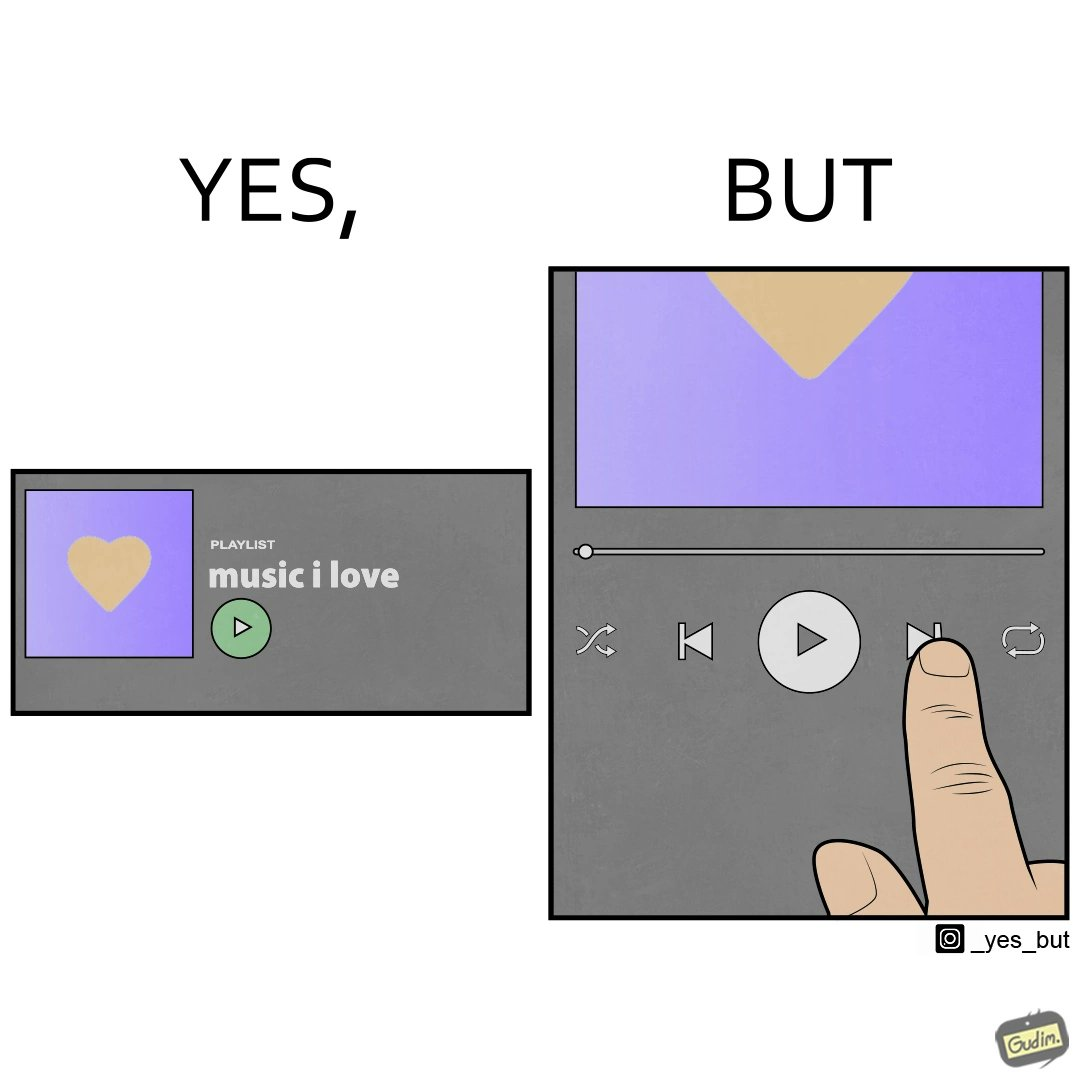Compare the left and right sides of this image. In the left part of the image: The image shows a playlist named "music I love" with a green play button. There is also an icon of yellow heart with purple background. In the right part of the image: The image shows the next button being pressed on a music application with only a few seconds into the current music. 